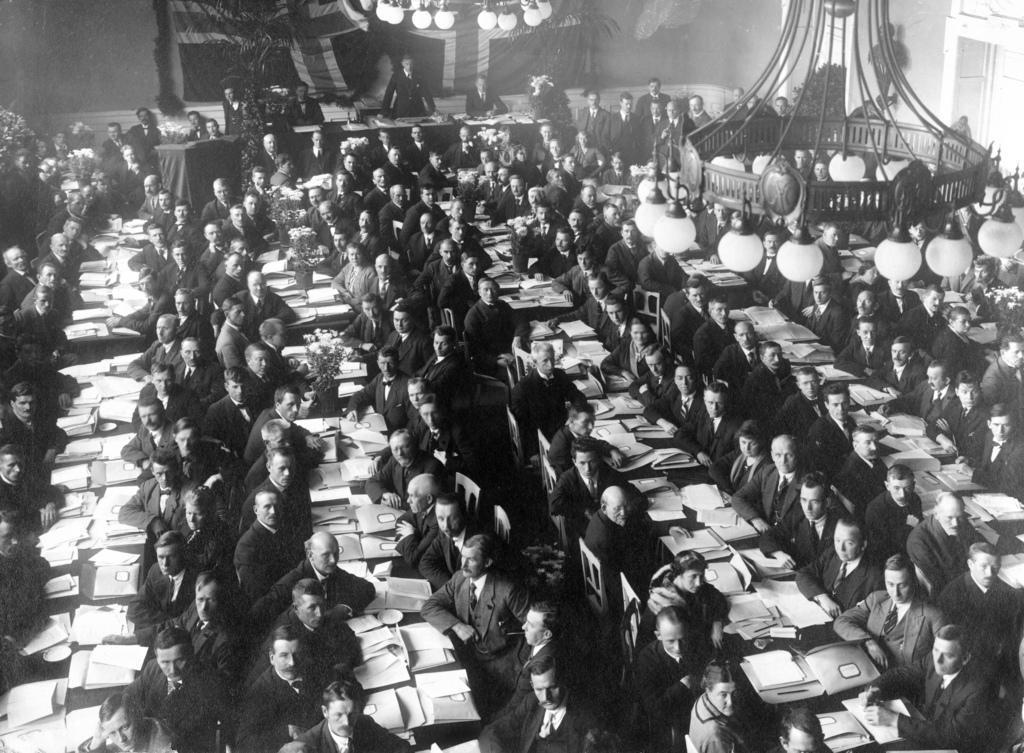In one or two sentences, can you explain what this image depicts? This is a black and white image, where we can see men sitting near the table on which papers and envelopes are on it. On the right top, there is a chandelier. In the background, there are men few are sitting and few are standing, a flag, wall and the plants. 